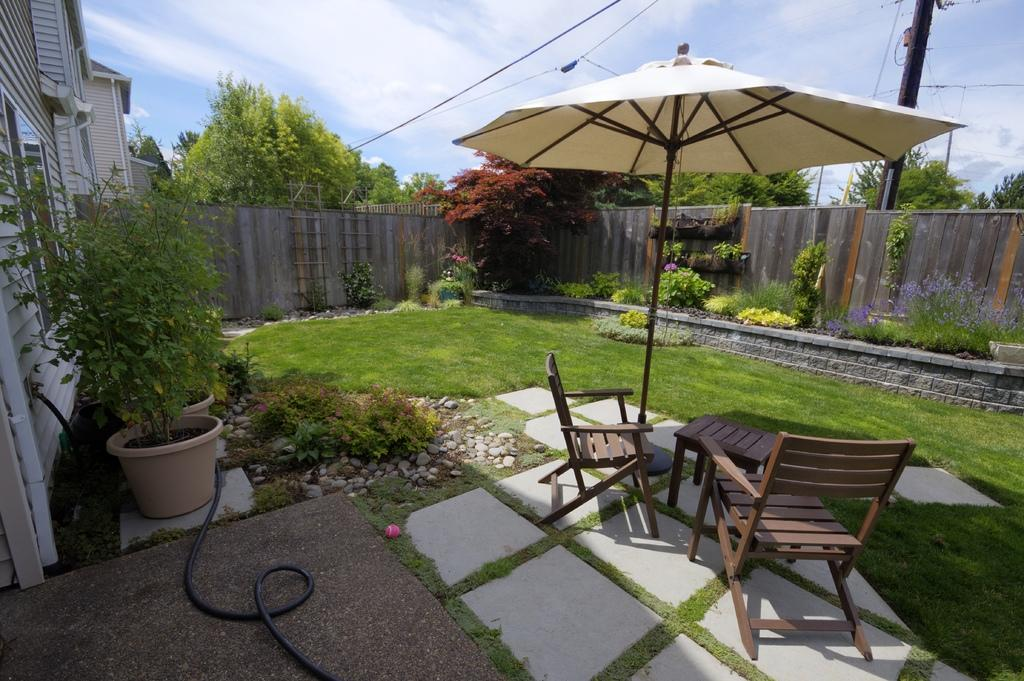What type of furniture is present in the image? There are tables in the image. What natural elements can be seen in the image? There are trees and plants in the image. What architectural feature is visible in the image? There is a wall in the image. What is the condition of the sky in the image? The sky is clear in the image. How many kittens are playing on the wall in the image? There are no kittens present in the image. What is the weight of the ghost in the image? There is no ghost present in the image, so it is not possible to determine its weight. 